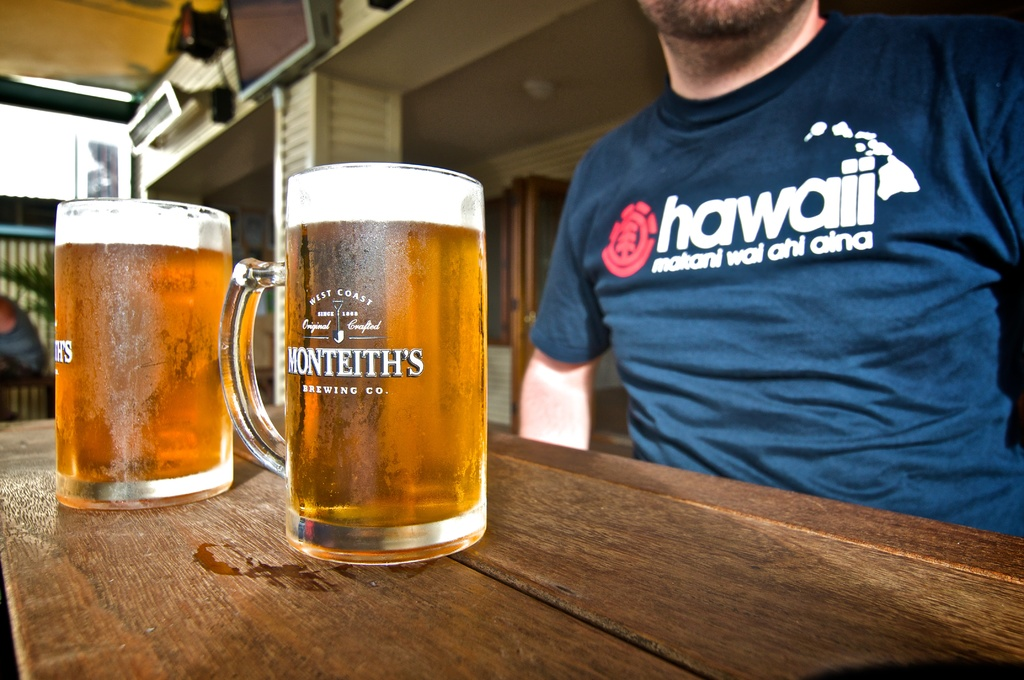Can you describe the branding visible on the beer mugs? The beer mugs are branded with 'Monteith's Brewing Co.', indicating that the beer served is from a west coast brewery renowned for its traditional brewing techniques. 